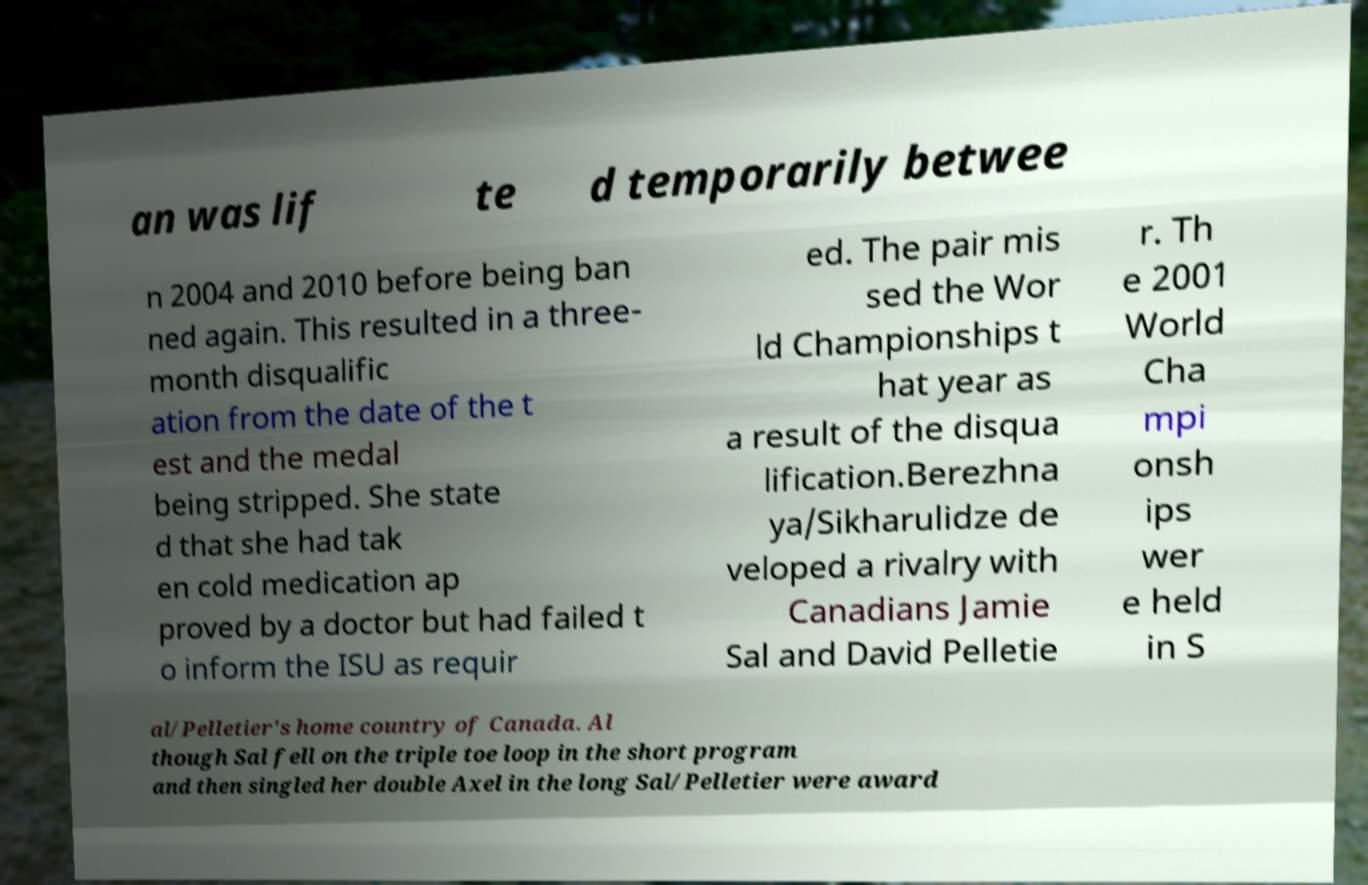I need the written content from this picture converted into text. Can you do that? an was lif te d temporarily betwee n 2004 and 2010 before being ban ned again. This resulted in a three- month disqualific ation from the date of the t est and the medal being stripped. She state d that she had tak en cold medication ap proved by a doctor but had failed t o inform the ISU as requir ed. The pair mis sed the Wor ld Championships t hat year as a result of the disqua lification.Berezhna ya/Sikharulidze de veloped a rivalry with Canadians Jamie Sal and David Pelletie r. Th e 2001 World Cha mpi onsh ips wer e held in S al/Pelletier's home country of Canada. Al though Sal fell on the triple toe loop in the short program and then singled her double Axel in the long Sal/Pelletier were award 